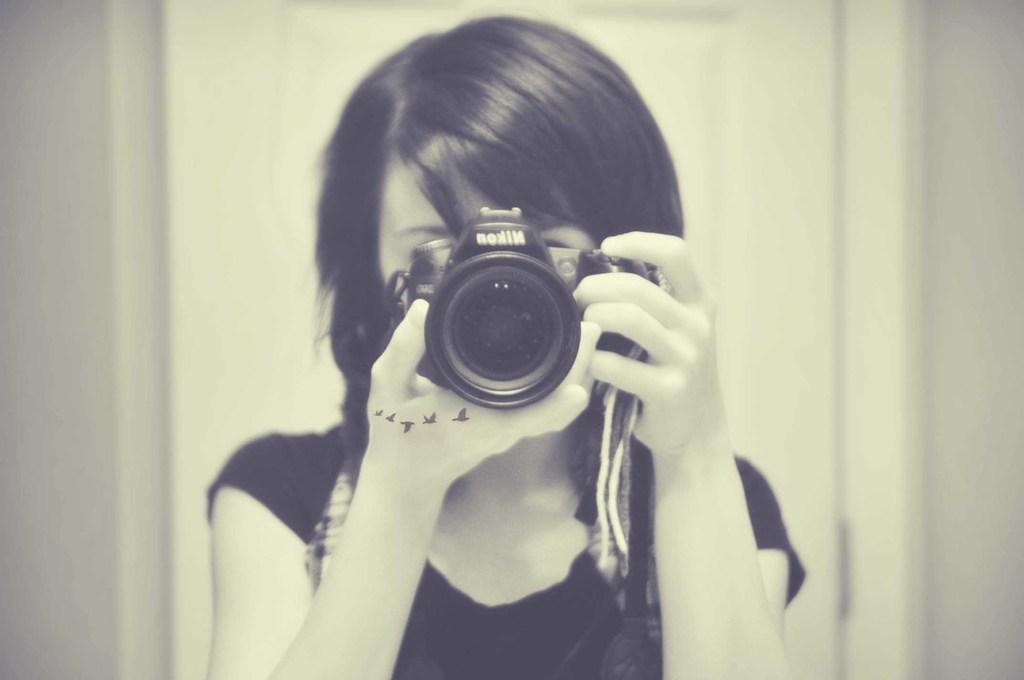What is the person in the image doing? The person is holding a camera in the image. What is the person wearing? The person is wearing a black dress. What color is the background of the image? The background of the image is white. Can you see any nests in the image? There are no nests present in the image. Is there a ship visible in the background of the image? There is no ship visible in the image; the background is white. 